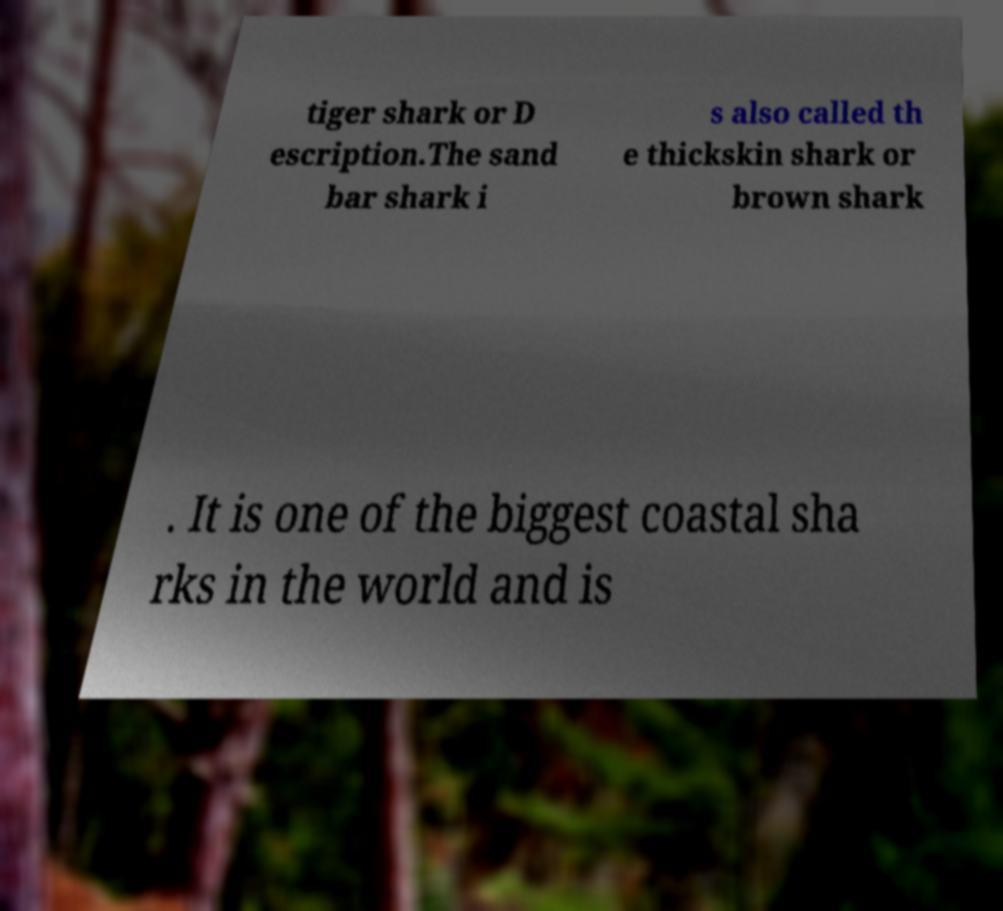There's text embedded in this image that I need extracted. Can you transcribe it verbatim? tiger shark or D escription.The sand bar shark i s also called th e thickskin shark or brown shark . It is one of the biggest coastal sha rks in the world and is 